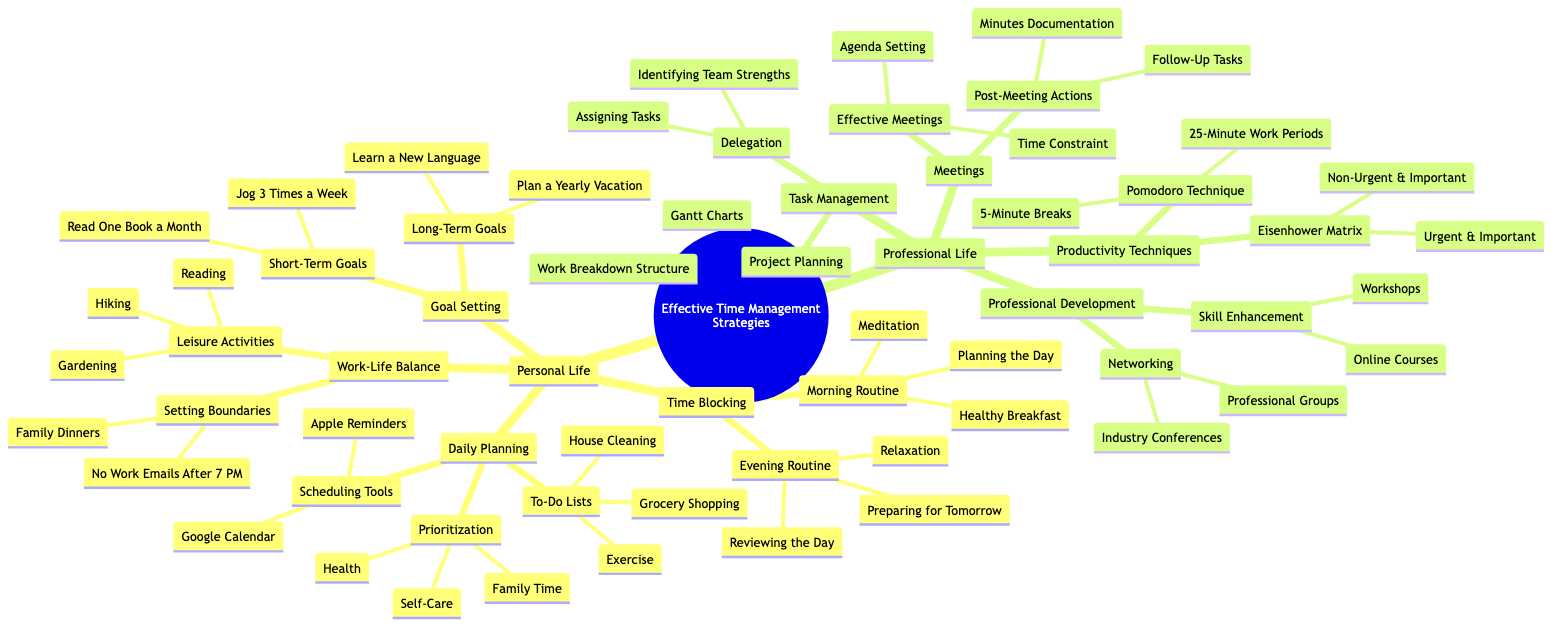What are two tools mentioned under Daily Planning? In the diagram under the "Daily Planning" section, there are two specific nodes listed under "Scheduling Tools," which are "Google Calendar" and "Apple Reminders."
Answer: Google Calendar, Apple Reminders How many types of Professional Development strategies are listed? The "Professional Development" category contains two strategies: "Skill Enhancement" and "Networking." Thus, the total number of types is two.
Answer: 2 What is one Long-Term Goal listed in the Goal Setting section? In the "Goal Setting" section under "Long-Term Goals," there are two items, one of which is "Learn a New Language."
Answer: Learn a New Language What is the main focus of the Task Management category? The "Task Management" category primarily focuses on two areas, which are "Project Planning" and "Delegation," indicating how tasks should be managed in a professional setting.
Answer: Project Planning, Delegation Which technique involves 25-Minute work periods? Under the "Productivity Techniques" section, the technique that involves 25-Minute work periods is known as the "Pomodoro Technique."
Answer: Pomodoro Technique Name one element under the Work-Life Balance category. The "Work-Life Balance" category includes several elements, one of which is "Setting Boundaries."
Answer: Setting Boundaries What is the purpose of Post-Meeting Actions? In the "Meetings" category, the "Post-Meeting Actions" segment addresses activities that should be fulfilled after meetings, such as "Minutes Documentation" and "Follow-Up Tasks." Thus, their purpose is to document and ensure actions are taken post-meeting.
Answer: Minutes Documentation, Follow-Up Tasks What should one include in their Evening Routine according to the Time Blocking section? The "Evening Routine" in the "Time Blocking" section specifies three activities: "Relaxation," "Reviewing the Day," and "Preparing for Tomorrow," indicating what should be prioritized in the evening.
Answer: Relaxation, Reviewing the Day, Preparing for Tomorrow What prioritization is emphasized in Daily Planning? In the "Prioritization" node under the "Daily Planning" section, three aspects are highlighted: "Health," "Family Time," and "Self-Care," which emphasize what should be prioritized daily.
Answer: Health, Family Time, Self-Care 